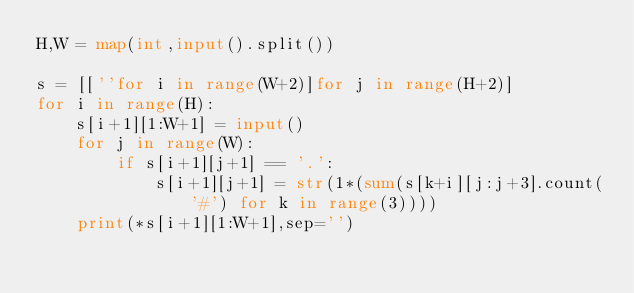<code> <loc_0><loc_0><loc_500><loc_500><_Python_>H,W = map(int,input().split())

s = [[''for i in range(W+2)]for j in range(H+2)]
for i in range(H):
    s[i+1][1:W+1] = input()
    for j in range(W):
        if s[i+1][j+1] == '.':
            s[i+1][j+1] = str(1*(sum(s[k+i][j:j+3].count('#') for k in range(3))))
    print(*s[i+1][1:W+1],sep='')
</code> 